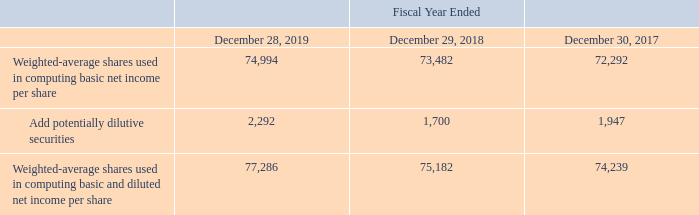Net Income Per Share
Basic net income per share is computed by dividing net income by the weighted-average number of common shares outstanding for the period. Diluted net income per share is computed giving effect to all potentially dilutive common stock and common stock equivalents, including stock options, RSUs and common stock subject to repurchase.
The following table reconciles the shares used in calculating basic net income per share and diluted net income per share (in thousands):
What is the Weighted-average shares used in computing basic and diluted net income per share in 2019?
Answer scale should be: thousand. 77,286. What is the change in Weighted-average shares used in computing basic net income per share from Fiscal Year Ended December 28, 2019 to December 29, 2018?
Answer scale should be: thousand. 74,994-73,482
Answer: 1512. What is the change in Weighted-average shares used in computing basic and diluted net income per share from Fiscal Year Ended December 28, 2019 to December 29, 2018?
Answer scale should be: thousand. 77,286-75,182
Answer: 2104. In which year was Add potentially dilutive securities less than 2,000 thousands? Locate and analyze add potentially dilutive securities in row 4
answer: 2018, 2017. What was the Weighted-average shares used in computing basic net income per share in 2019, 2018 and 2017 respectively?
Answer scale should be: thousand. 74,994, 73,482, 72,292. How is the basic net income per share calculated? Computed by dividing net income by the weighted-average number of common shares outstanding for the period. 